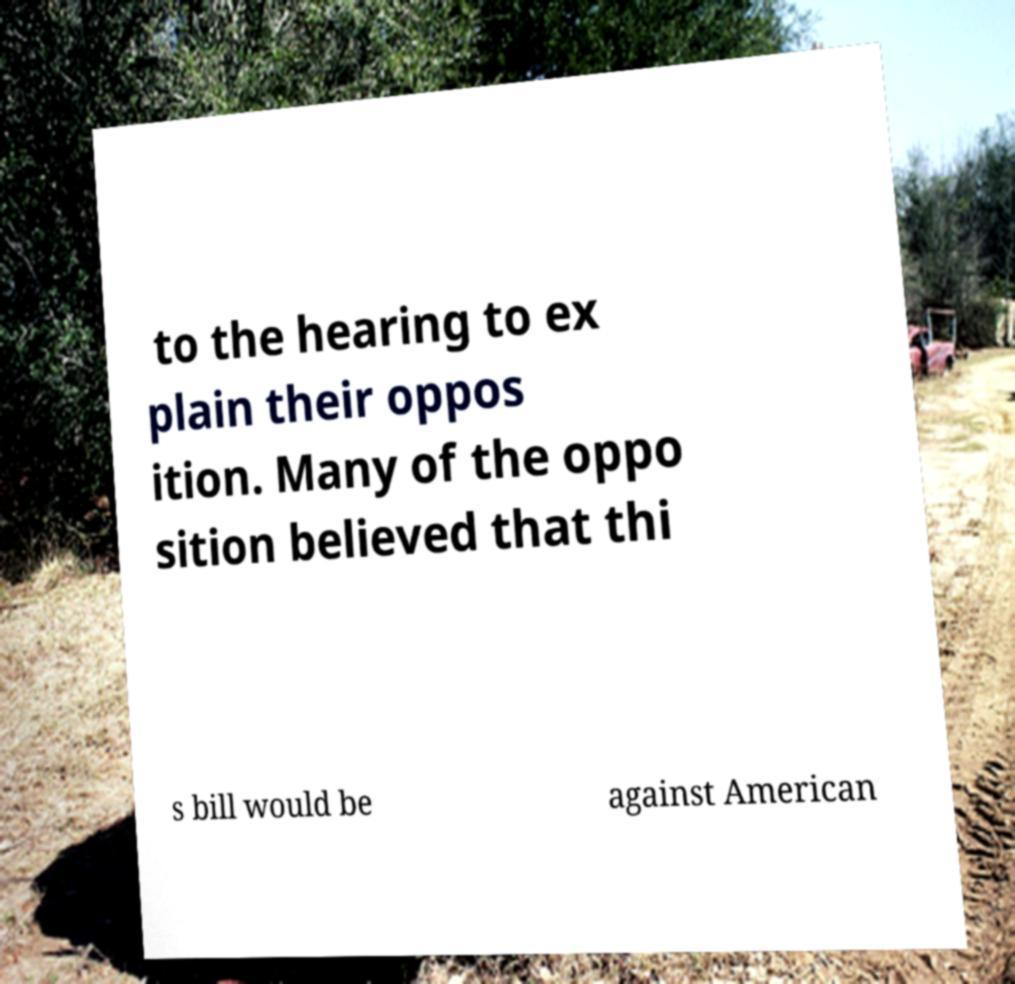I need the written content from this picture converted into text. Can you do that? to the hearing to ex plain their oppos ition. Many of the oppo sition believed that thi s bill would be against American 